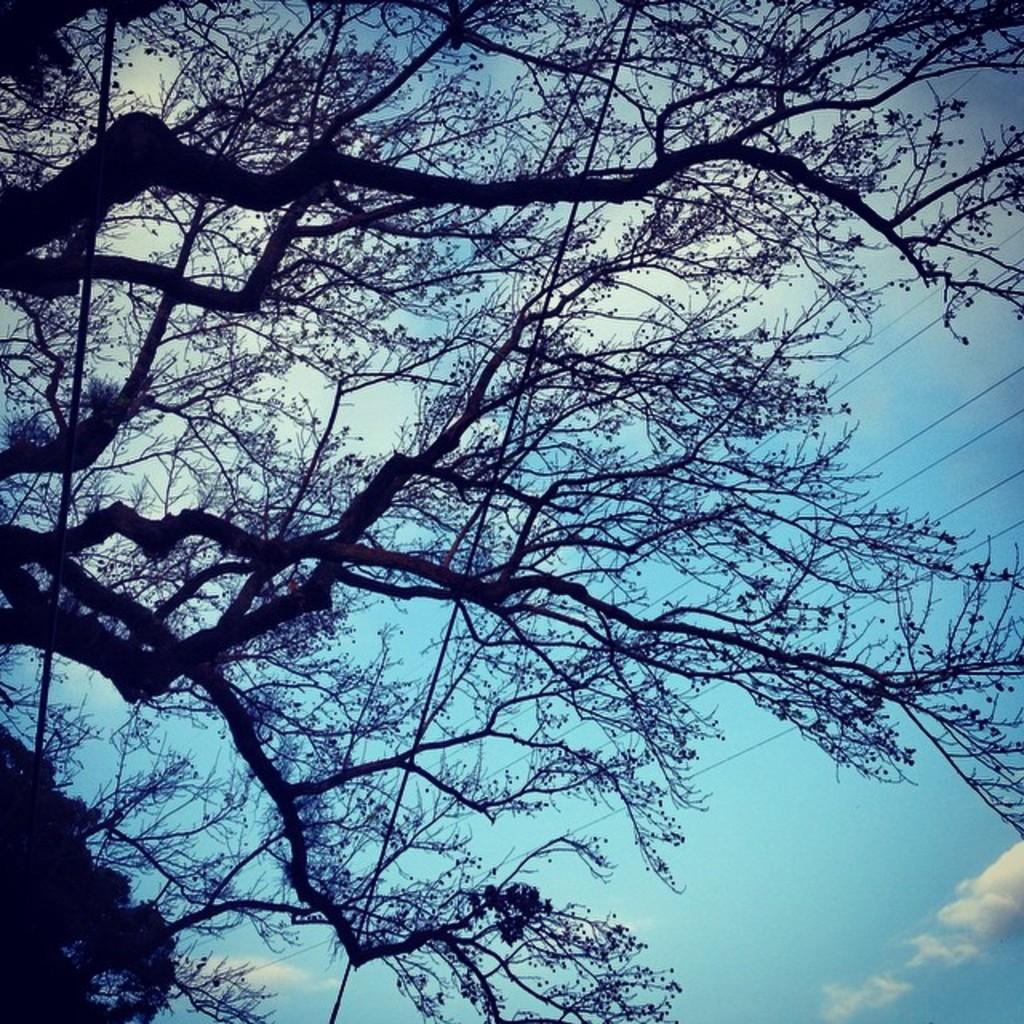How would you summarize this image in a sentence or two? In this picture we can see three, wires are there. In the background of the image clouds are present in the sky. 